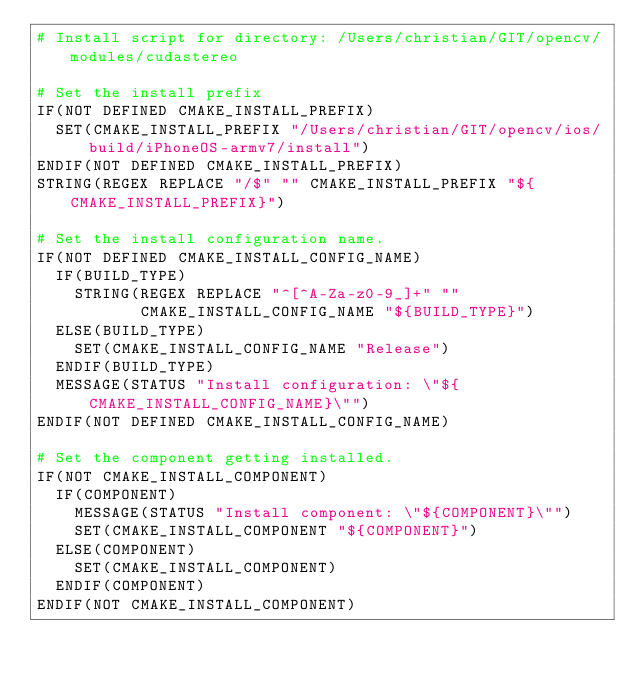Convert code to text. <code><loc_0><loc_0><loc_500><loc_500><_CMake_># Install script for directory: /Users/christian/GIT/opencv/modules/cudastereo

# Set the install prefix
IF(NOT DEFINED CMAKE_INSTALL_PREFIX)
  SET(CMAKE_INSTALL_PREFIX "/Users/christian/GIT/opencv/ios/build/iPhoneOS-armv7/install")
ENDIF(NOT DEFINED CMAKE_INSTALL_PREFIX)
STRING(REGEX REPLACE "/$" "" CMAKE_INSTALL_PREFIX "${CMAKE_INSTALL_PREFIX}")

# Set the install configuration name.
IF(NOT DEFINED CMAKE_INSTALL_CONFIG_NAME)
  IF(BUILD_TYPE)
    STRING(REGEX REPLACE "^[^A-Za-z0-9_]+" ""
           CMAKE_INSTALL_CONFIG_NAME "${BUILD_TYPE}")
  ELSE(BUILD_TYPE)
    SET(CMAKE_INSTALL_CONFIG_NAME "Release")
  ENDIF(BUILD_TYPE)
  MESSAGE(STATUS "Install configuration: \"${CMAKE_INSTALL_CONFIG_NAME}\"")
ENDIF(NOT DEFINED CMAKE_INSTALL_CONFIG_NAME)

# Set the component getting installed.
IF(NOT CMAKE_INSTALL_COMPONENT)
  IF(COMPONENT)
    MESSAGE(STATUS "Install component: \"${COMPONENT}\"")
    SET(CMAKE_INSTALL_COMPONENT "${COMPONENT}")
  ELSE(COMPONENT)
    SET(CMAKE_INSTALL_COMPONENT)
  ENDIF(COMPONENT)
ENDIF(NOT CMAKE_INSTALL_COMPONENT)

</code> 